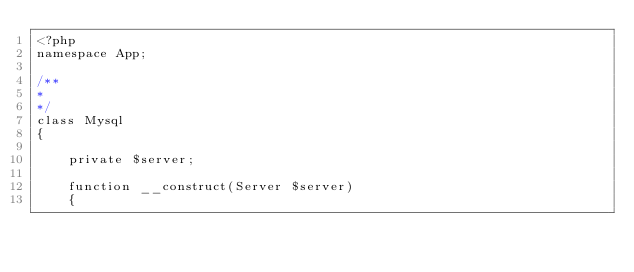Convert code to text. <code><loc_0><loc_0><loc_500><loc_500><_PHP_><?php
namespace App;

/**
* 
*/
class Mysql
{
	
	private $server;

	function __construct(Server $server)
	{</code> 